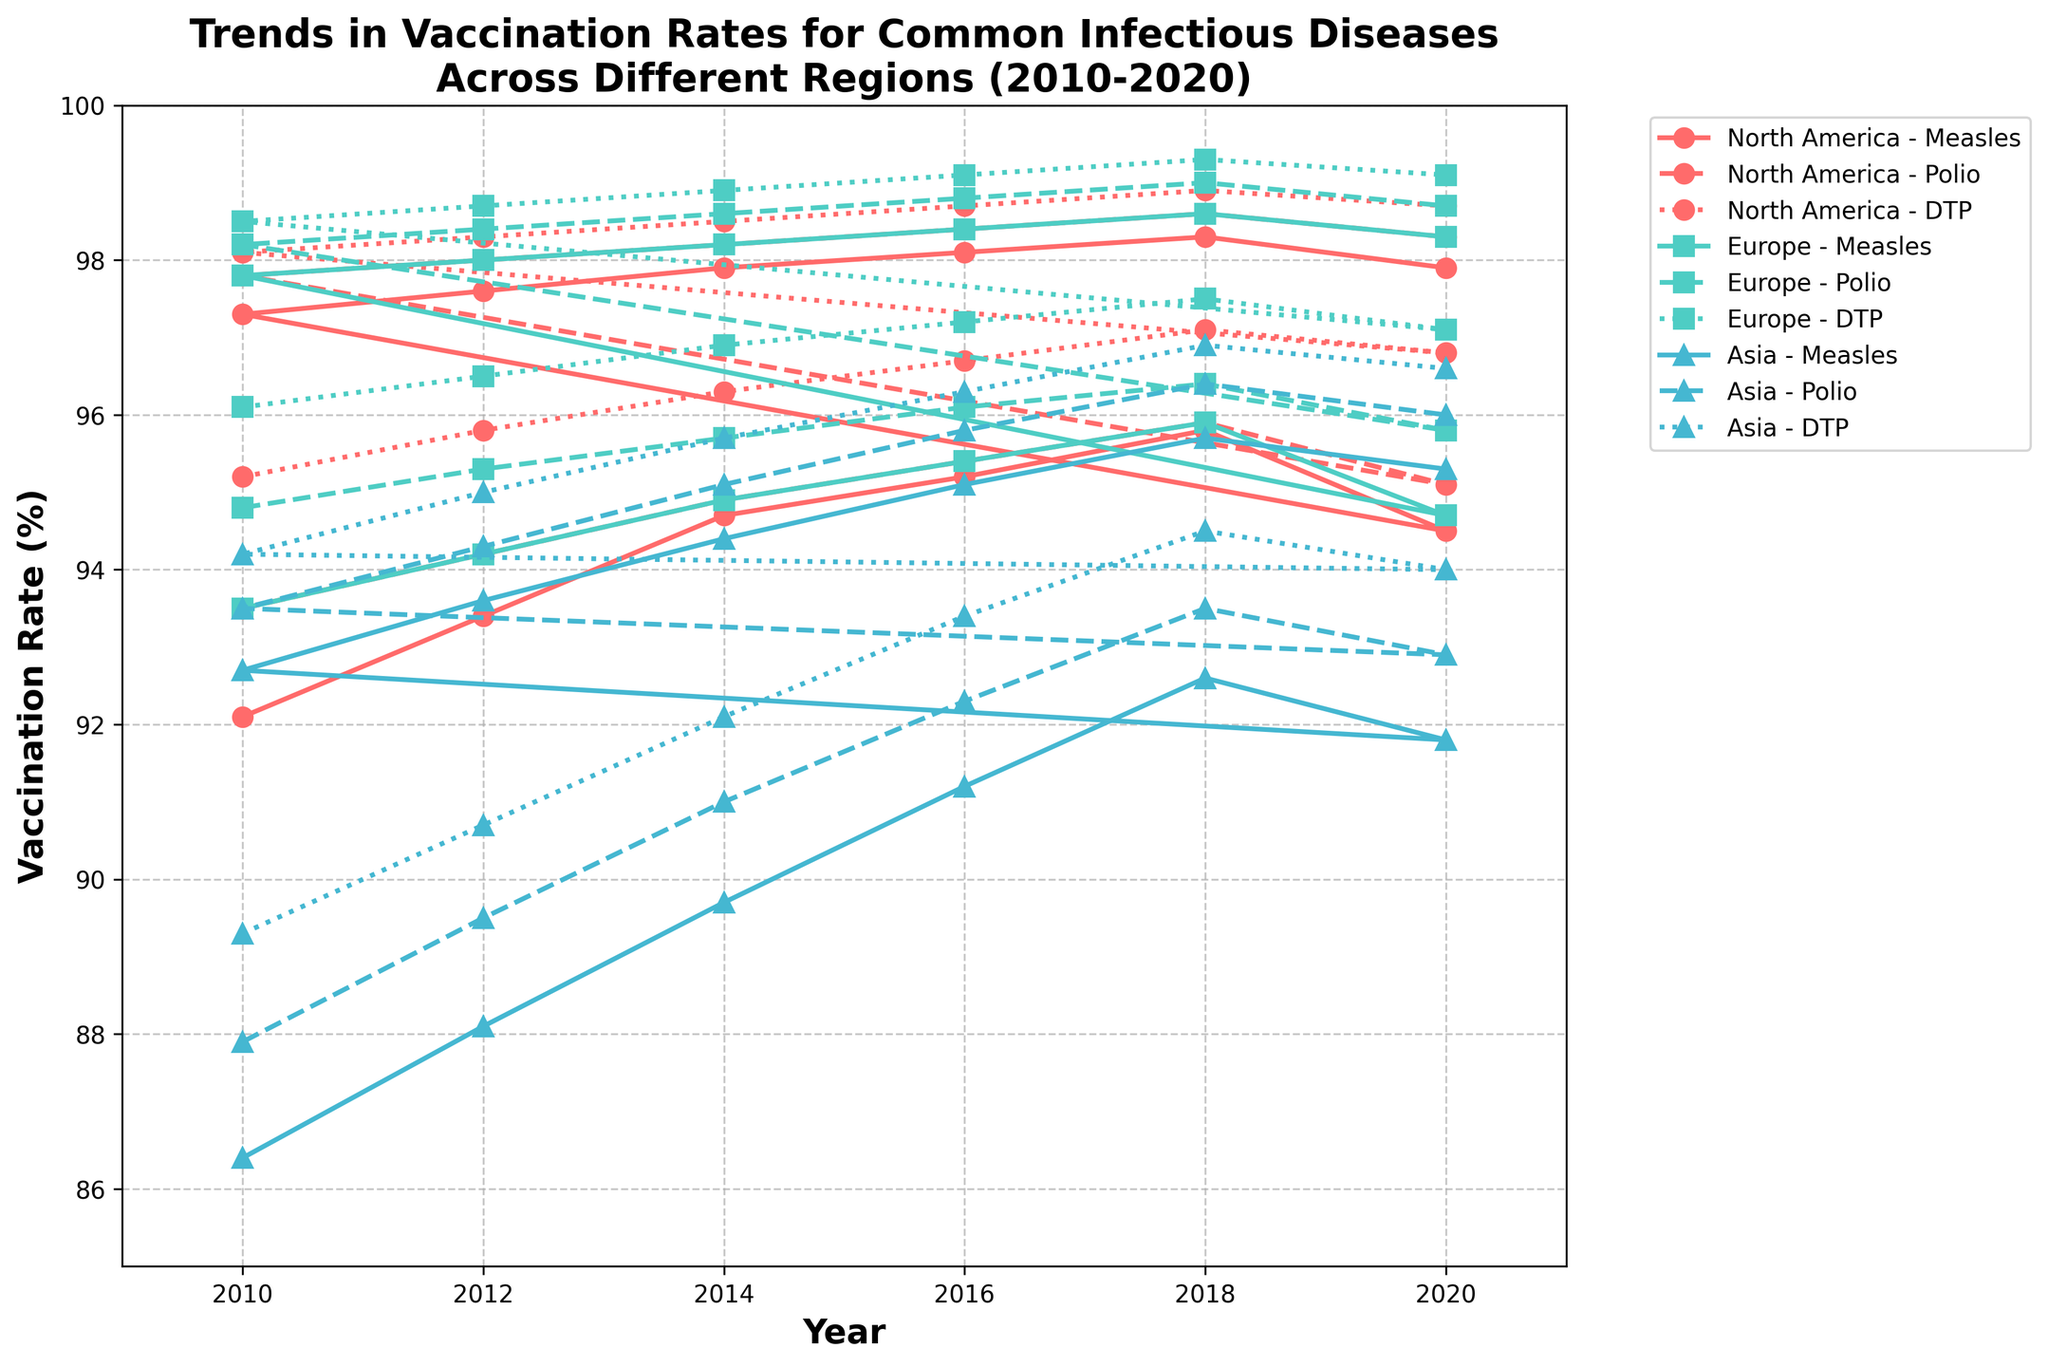What general trends can be observed in the vaccination rates for the age group 0-4 across all regions from 2010 to 2020? The trends observed in the age group 0-4 across North America, Europe, and Asia show an increase in vaccination rates for Measles, Polio, and Diphtheria-Tetanus-Pertussis (DTP) until around 2018, followed by a slight decline by 2020.
Answer: Increasing trend until 2018, then slight decline Which region had the highest DTP vaccination rate in 2020 for the age group 5-14? By examining the rates within the figure, Europe has the highest DTP vaccination rate at around 99.1% in 2020 for the age group 5-14.
Answer: Europe How did the Measles vaccination rate for the age group 0-4 in North America change between 2010 and 2020? Referencing the visual line for North America (marked in a unique color and style for Measles), the rate increased from 92.1% in 2010 to a peak of 95.8% in 2018 before dropping slightly to 94.5% in 2020.
Answer: Increased from 92.1% to 94.5% Which age group had relatively more stable vaccination rates across all regions, 0-4 or 5-14? Observing the overall trends, the age group 5-14 shows more stable vaccination rates across North America, Europe, and Asia compared to the age group 0-4, where more fluctuations are seen.
Answer: 5-14 What is the combined average vaccination rate of Polio for the age group 5-14 across all regions in 2018? Calculate the average by summing the Polio vaccination rates for North America (98.6), Europe (99.0), and Asia (96.4), then dividing by 3. (98.6 + 99.0 + 96.4) / 3 = 294 / 3
Answer: 98.0% Between 2014 and 2016, which region saw the most significant increase in Measles vaccination rate for the age group 0-4? By comparing each region's Measles vaccination rates, Asia saw a significant increase from 89.7% in 2014 to 91.2% in 2016, an increase of 1.5 percentage points, which is more substantial compared to other regions.
Answer: Asia Which infectious disease vaccination rate, among those shown in the figure, had the lowest rate in Asia for the age group 0-4 in 2012? By examining the lines and markers for Asia in 2012, the DTP (Diphtheria-Tetanus-Pertussis) vaccination rate was the lowest, around 90.7%.
Answer: DTP What are the average vaccination rates for Measles, Polio, and DTP in Europe for the age group 0-4 in 2020? Calculate separately: Measles (94.7%), Polio (95.8%), and DTP (97.1%). Average = (94.7 + 95.8 + 97.1) / 3 = 287.6 / 3
Answer: 95.87% Across all regions, which age group had a higher Polio vaccination rate in 2010? Compare the Polio vaccination rates for the age groups 0-4 and 5-14 across North America, Europe, and Asia. The age group 5-14 consistently had higher rates in all regions.
Answer: 5-14 